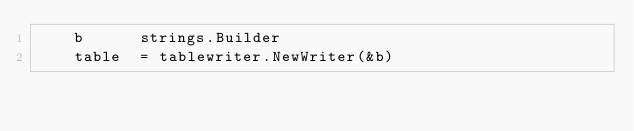<code> <loc_0><loc_0><loc_500><loc_500><_Go_>		b      strings.Builder
		table  = tablewriter.NewWriter(&b)</code> 